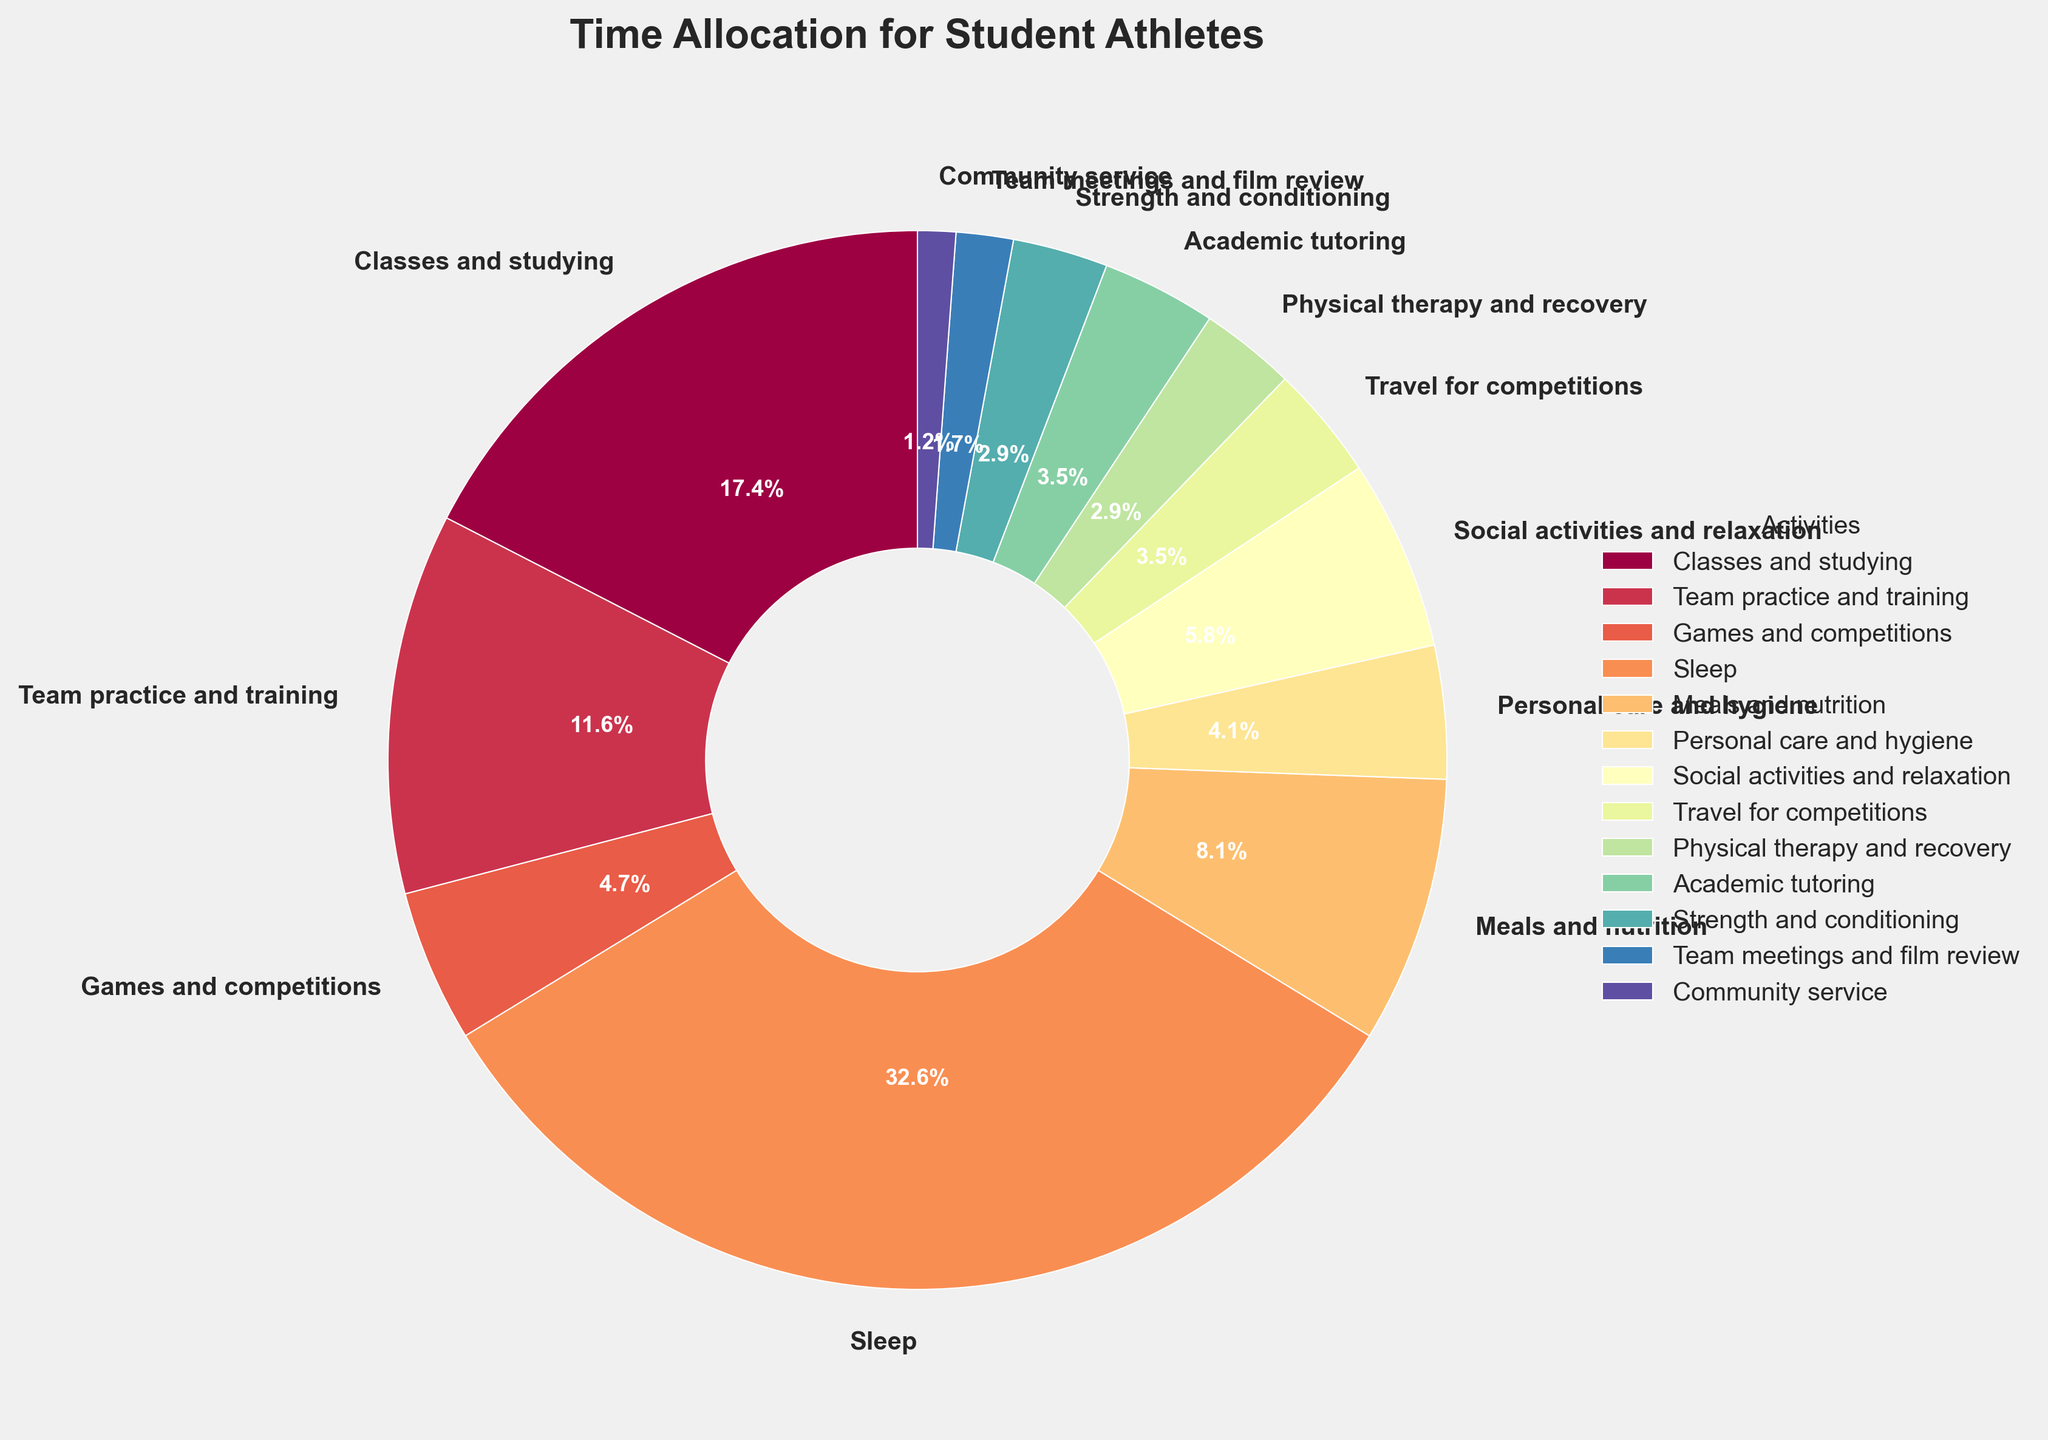What's the total amount of time spent on team activities (including practice, games, travel, meetings, and strength and conditioning)? Add the hours for "Team practice and training" (20), "Games and competitions" (8), "Travel for competitions" (6), "Team meetings and film review" (3), and "Strength and conditioning" (5). Total = 20 + 8 + 6 + 3 + 5 = 42 hours.
Answer: 42 hours Which activity consumes the largest proportion of time? The activity section with the largest wedge in the pie chart and the highest percentage label is "Sleep," which occupies 56 hours per week.
Answer: Sleep How much more time is spent on sleeping compared to studying and classes? The time spent on "Sleep" is 56 hours, while "Classes and studying" takes 30 hours. The difference is 56 - 30 = 26 hours.
Answer: 26 hours Which activity is represented by the smallest wedge in the pie chart? The smallest wedge in the pie chart represents "Community service," taking up 2 hours per week.
Answer: Community service What percentage of time is spent on meals and nutrition? The pie chart indicates "Meals and nutrition" with a specific wedge and label showing 14 hours. The corresponding percentage is derived from 14 hours out of a total week (168 hours) and displayed on the pie chart.
Answer: 8.3% Compare the time spent on academic activities (studying and tutoring) versus physical activities (practice, games, recovery, strength and conditioning). Which is greater? Academic activities include "Classes and studying" (30 hours) and "Academic tutoring" (6 hours) totaling 36 hours. Physical activities include "Team practice and training" (20 hours), "Games and competitions" (8 hours), "Physical therapy and recovery" (5 hours), and "Strength and conditioning" (5 hours) summing up to 38 hours. 38 > 36.
Answer: Physical activities What is the percentage of time spent on social activities and relaxation compared to the total time allocated? The "Social activities and relaxation" section represents 10 hours per week. Percentage = (10 / 168) * 100 ≈ 6%.
Answer: 6% Is more time spent on meals and nutrition or on personal care and hygiene? The chart shows 14 hours for "Meals and nutrition" and 7 hours for "Personal care and hygiene." 14 > 7, so more time is spent on meals and nutrition.
Answer: Meals and nutrition Calculate the combined percentage of time spent on travel and community service activities. Travel for competitions is 6 hours and Community service is 2 hours. Total combined is 6 + 2 = 8 hours. Percentage = (8 / 168) * 100 ≈ 4.8%.
Answer: 4.8% How many more hours per week are spent on team practice and training compared to physical therapy and recovery? Team practice and training takes 20 hours, while physical therapy and recovery takes 5 hours. The difference is 20 - 5 = 15 hours.
Answer: 15 hours 